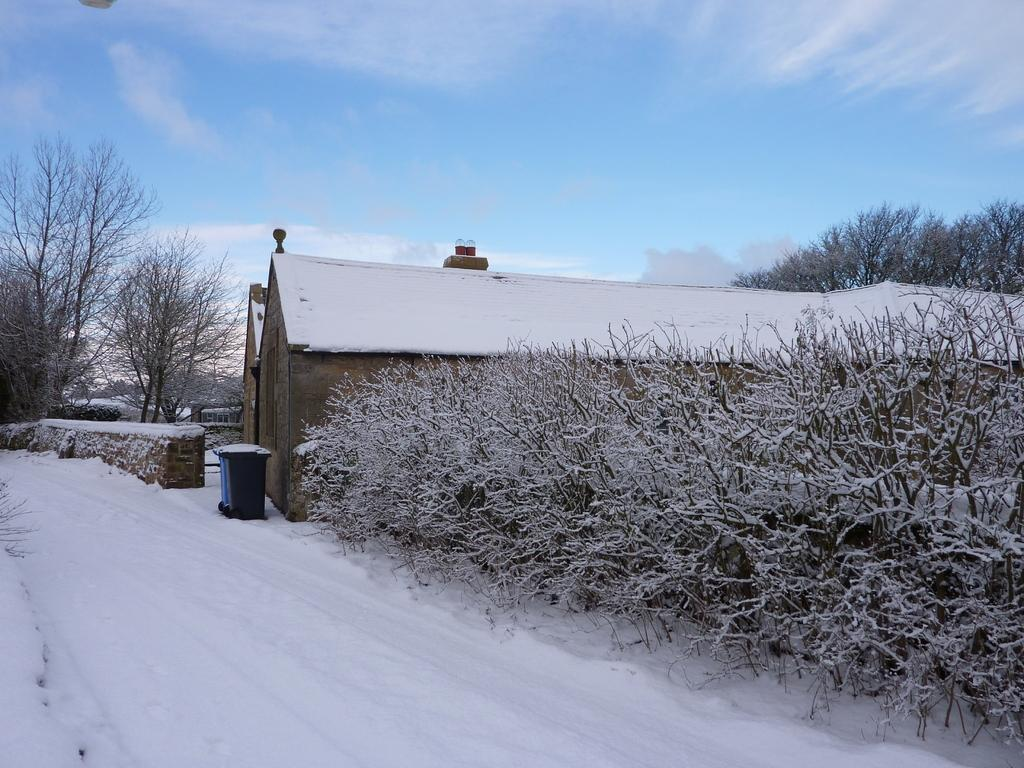How many houses are visible in the image? There are two houses in the image. What is the condition of the trees around the houses? The trees around the houses are covered with snow. What is the state of the path in front of the houses? The path in front of the houses is filled with dense ice. What type of joke is being told by the family in the image? There is no family present in the image, nor is there any indication of a joke being told. 